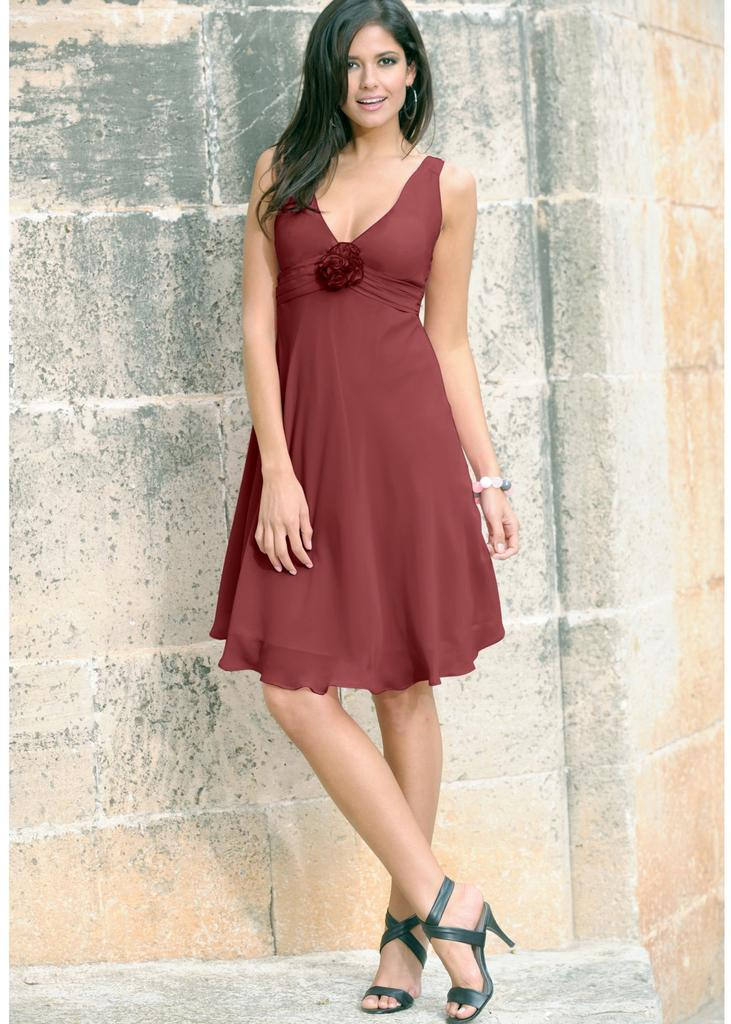Who is the main subject in the image? There is a woman in the image. What is the woman wearing? The woman is wearing a brown dress. What can be seen in the background of the image? There is a wall in the background of the image. What is visible at the bottom of the image? There is a ground visible at the bottom of the image. What invention is the woman holding in the image? There is no invention visible in the image; the woman is simply standing and wearing a brown dress. 